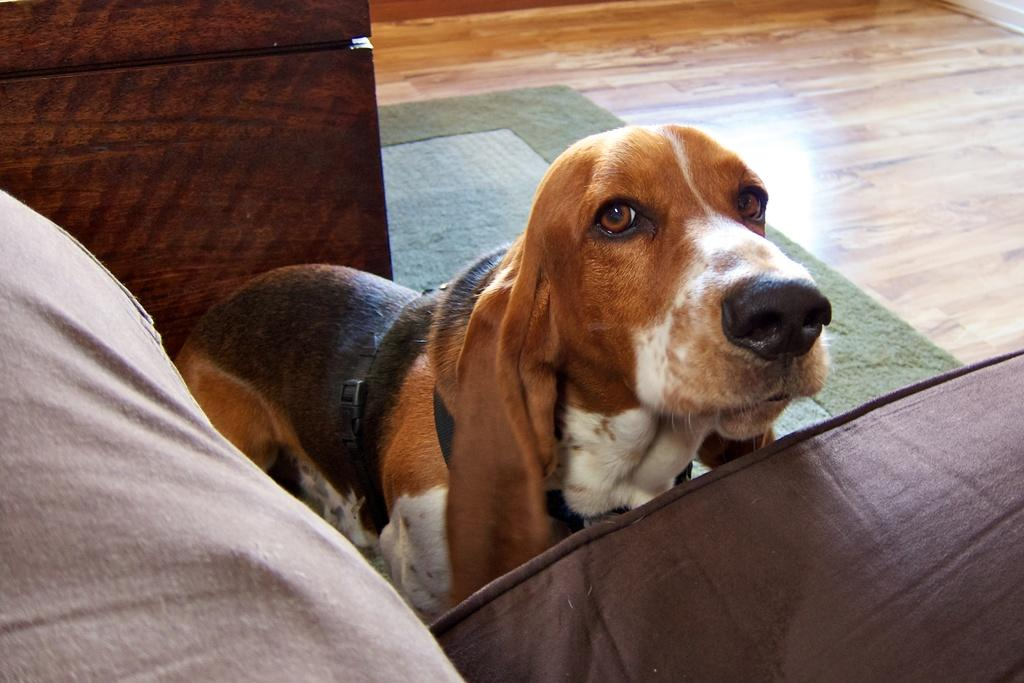What is the person in the image doing? The person is sitting on the sofa in the image. What animal is present in the image? There is a dog standing in the image. What type of object can be seen at the back of the image? There is a wooden object at the back of the image. What is the surface that the sofa and dog are standing on? There is a floor visible in the image. What is placed on the floor in the image? There is a mat on the floor. What type of medical advice is the person seeking from the doctor in the image? There is no doctor present in the image, so no medical advice can be sought. 